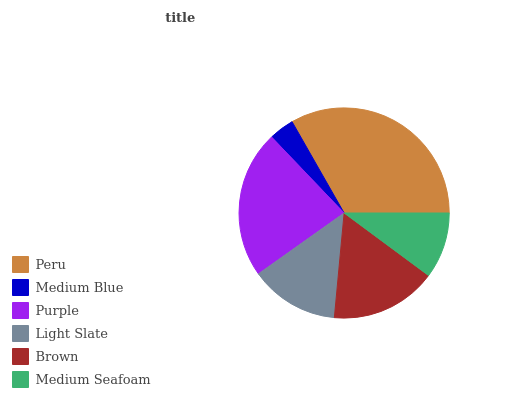Is Medium Blue the minimum?
Answer yes or no. Yes. Is Peru the maximum?
Answer yes or no. Yes. Is Purple the minimum?
Answer yes or no. No. Is Purple the maximum?
Answer yes or no. No. Is Purple greater than Medium Blue?
Answer yes or no. Yes. Is Medium Blue less than Purple?
Answer yes or no. Yes. Is Medium Blue greater than Purple?
Answer yes or no. No. Is Purple less than Medium Blue?
Answer yes or no. No. Is Brown the high median?
Answer yes or no. Yes. Is Light Slate the low median?
Answer yes or no. Yes. Is Purple the high median?
Answer yes or no. No. Is Brown the low median?
Answer yes or no. No. 